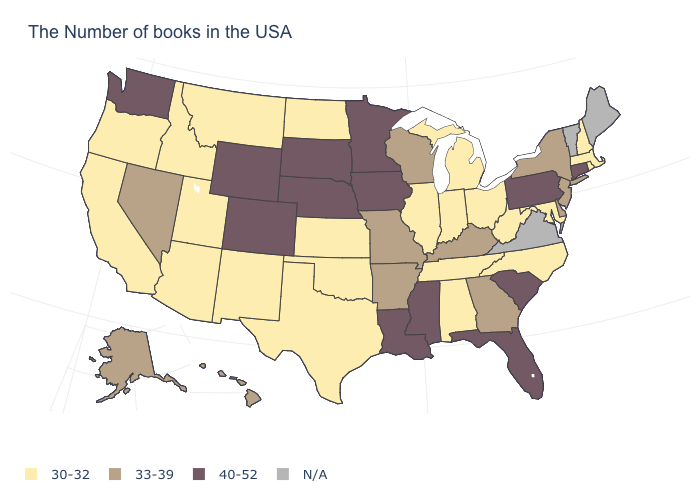Name the states that have a value in the range 40-52?
Write a very short answer. Connecticut, Pennsylvania, South Carolina, Florida, Mississippi, Louisiana, Minnesota, Iowa, Nebraska, South Dakota, Wyoming, Colorado, Washington. What is the value of Maine?
Keep it brief. N/A. What is the value of Iowa?
Quick response, please. 40-52. How many symbols are there in the legend?
Write a very short answer. 4. Does the map have missing data?
Write a very short answer. Yes. Name the states that have a value in the range 40-52?
Write a very short answer. Connecticut, Pennsylvania, South Carolina, Florida, Mississippi, Louisiana, Minnesota, Iowa, Nebraska, South Dakota, Wyoming, Colorado, Washington. Name the states that have a value in the range N/A?
Answer briefly. Maine, Vermont, Virginia. What is the highest value in the USA?
Short answer required. 40-52. Name the states that have a value in the range 33-39?
Answer briefly. New York, New Jersey, Delaware, Georgia, Kentucky, Wisconsin, Missouri, Arkansas, Nevada, Alaska, Hawaii. Name the states that have a value in the range 40-52?
Be succinct. Connecticut, Pennsylvania, South Carolina, Florida, Mississippi, Louisiana, Minnesota, Iowa, Nebraska, South Dakota, Wyoming, Colorado, Washington. What is the value of Mississippi?
Be succinct. 40-52. Does the map have missing data?
Short answer required. Yes. What is the value of Florida?
Answer briefly. 40-52. Among the states that border Arkansas , which have the lowest value?
Concise answer only. Tennessee, Oklahoma, Texas. 